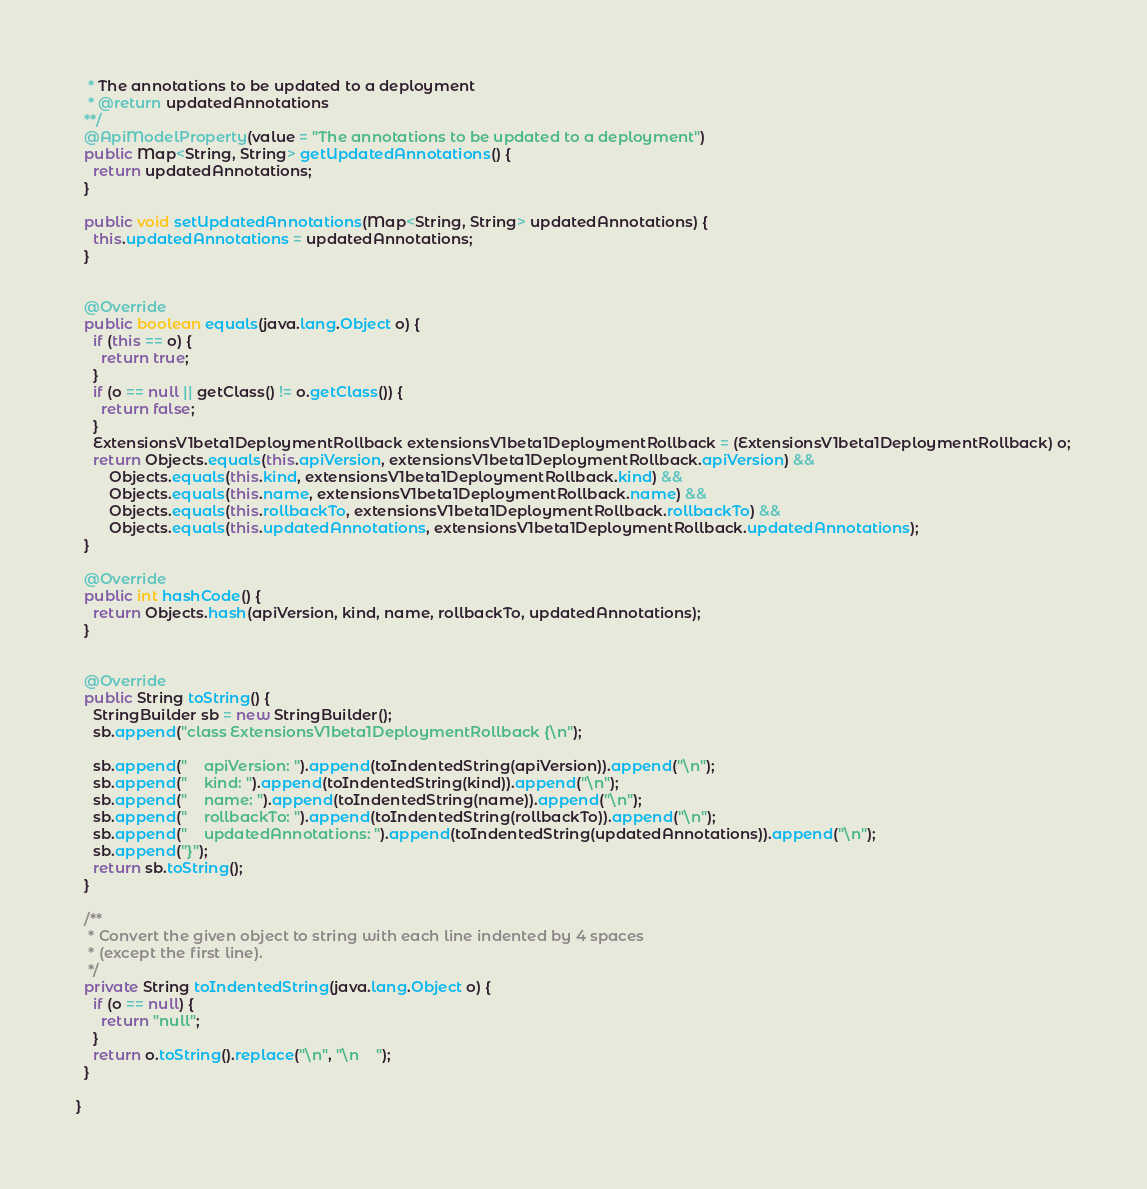<code> <loc_0><loc_0><loc_500><loc_500><_Java_>   * The annotations to be updated to a deployment
   * @return updatedAnnotations
  **/
  @ApiModelProperty(value = "The annotations to be updated to a deployment")
  public Map<String, String> getUpdatedAnnotations() {
    return updatedAnnotations;
  }

  public void setUpdatedAnnotations(Map<String, String> updatedAnnotations) {
    this.updatedAnnotations = updatedAnnotations;
  }


  @Override
  public boolean equals(java.lang.Object o) {
    if (this == o) {
      return true;
    }
    if (o == null || getClass() != o.getClass()) {
      return false;
    }
    ExtensionsV1beta1DeploymentRollback extensionsV1beta1DeploymentRollback = (ExtensionsV1beta1DeploymentRollback) o;
    return Objects.equals(this.apiVersion, extensionsV1beta1DeploymentRollback.apiVersion) &&
        Objects.equals(this.kind, extensionsV1beta1DeploymentRollback.kind) &&
        Objects.equals(this.name, extensionsV1beta1DeploymentRollback.name) &&
        Objects.equals(this.rollbackTo, extensionsV1beta1DeploymentRollback.rollbackTo) &&
        Objects.equals(this.updatedAnnotations, extensionsV1beta1DeploymentRollback.updatedAnnotations);
  }

  @Override
  public int hashCode() {
    return Objects.hash(apiVersion, kind, name, rollbackTo, updatedAnnotations);
  }


  @Override
  public String toString() {
    StringBuilder sb = new StringBuilder();
    sb.append("class ExtensionsV1beta1DeploymentRollback {\n");
    
    sb.append("    apiVersion: ").append(toIndentedString(apiVersion)).append("\n");
    sb.append("    kind: ").append(toIndentedString(kind)).append("\n");
    sb.append("    name: ").append(toIndentedString(name)).append("\n");
    sb.append("    rollbackTo: ").append(toIndentedString(rollbackTo)).append("\n");
    sb.append("    updatedAnnotations: ").append(toIndentedString(updatedAnnotations)).append("\n");
    sb.append("}");
    return sb.toString();
  }

  /**
   * Convert the given object to string with each line indented by 4 spaces
   * (except the first line).
   */
  private String toIndentedString(java.lang.Object o) {
    if (o == null) {
      return "null";
    }
    return o.toString().replace("\n", "\n    ");
  }

}

</code> 